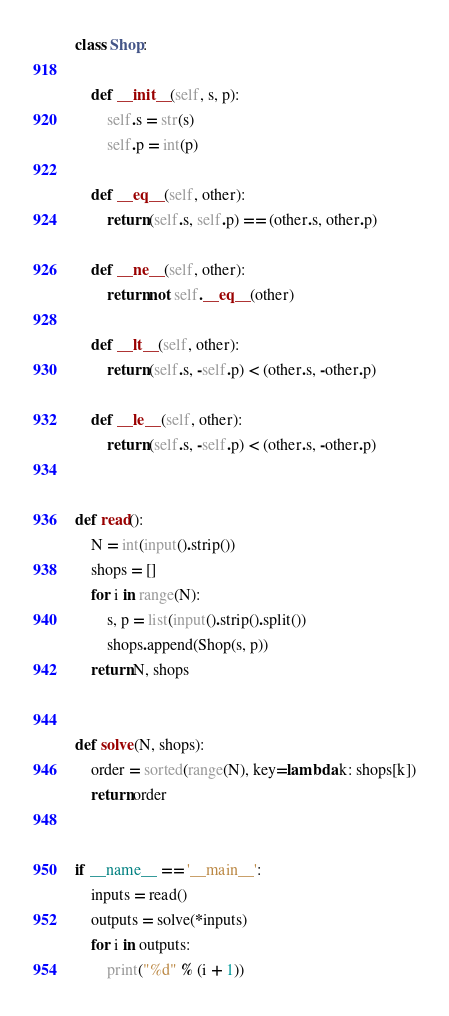Convert code to text. <code><loc_0><loc_0><loc_500><loc_500><_Python_>class Shop:

    def __init__(self, s, p):
        self.s = str(s)
        self.p = int(p)

    def __eq__(self, other):
        return (self.s, self.p) == (other.s, other.p)

    def __ne__(self, other):
        return not self.__eq__(other)

    def __lt__(self, other):
        return (self.s, -self.p) < (other.s, -other.p)

    def __le__(self, other):
        return (self.s, -self.p) < (other.s, -other.p)


def read():
    N = int(input().strip())
    shops = []
    for i in range(N):
        s, p = list(input().strip().split())
        shops.append(Shop(s, p))
    return N, shops


def solve(N, shops):
    order = sorted(range(N), key=lambda k: shops[k])
    return order


if __name__ == '__main__':
    inputs = read()
    outputs = solve(*inputs)
    for i in outputs:
        print("%d" % (i + 1))</code> 